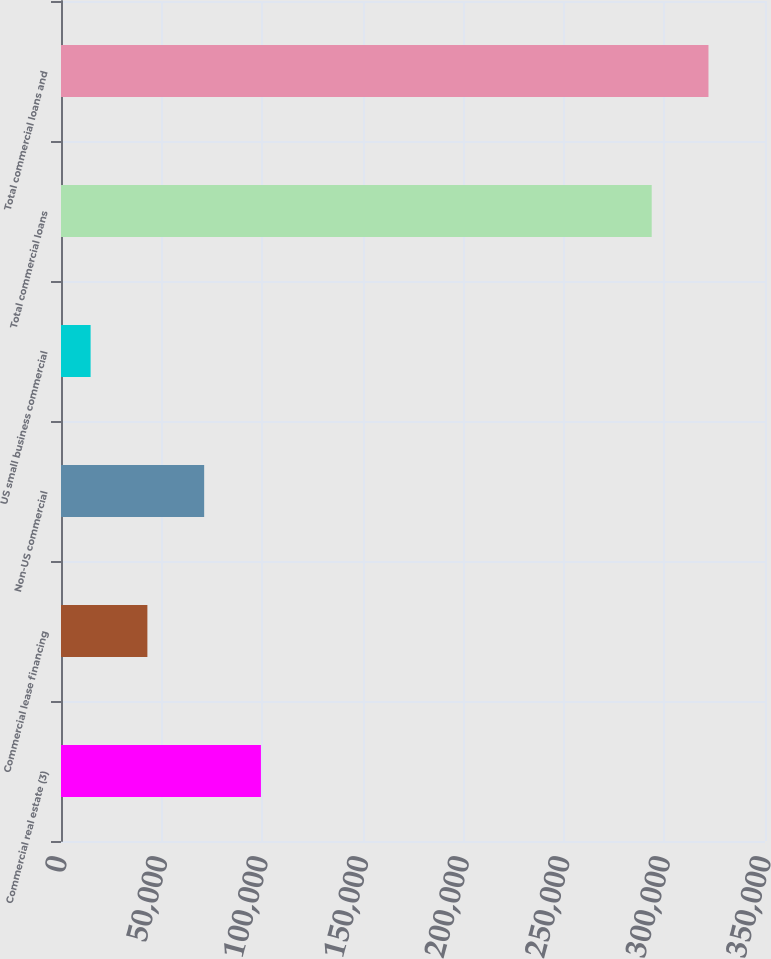Convert chart. <chart><loc_0><loc_0><loc_500><loc_500><bar_chart><fcel>Commercial real estate (3)<fcel>Commercial lease financing<fcel>Non-US commercial<fcel>US small business commercial<fcel>Total commercial loans<fcel>Total commercial loans and<nl><fcel>99400.3<fcel>42946.1<fcel>71173.2<fcel>14719<fcel>293669<fcel>321896<nl></chart> 